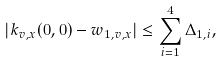<formula> <loc_0><loc_0><loc_500><loc_500>| k _ { v , x } ( 0 , 0 ) - w _ { 1 , v , x } | \leq \sum _ { i = 1 } ^ { 4 } \Delta _ { 1 , i } ,</formula> 